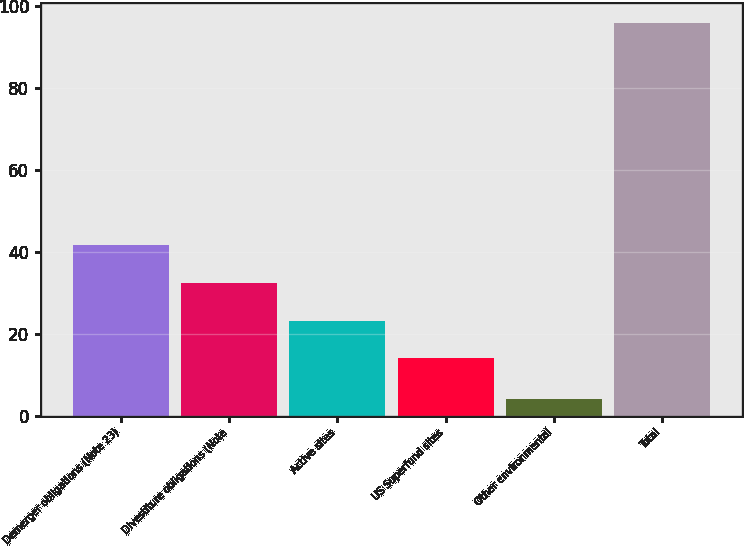Convert chart. <chart><loc_0><loc_0><loc_500><loc_500><bar_chart><fcel>Demerger obligations (Note 23)<fcel>Divestiture obligations (Note<fcel>Active sites<fcel>US Superfund sites<fcel>Other environmental<fcel>Total<nl><fcel>41.6<fcel>32.4<fcel>23.2<fcel>14<fcel>4<fcel>96<nl></chart> 